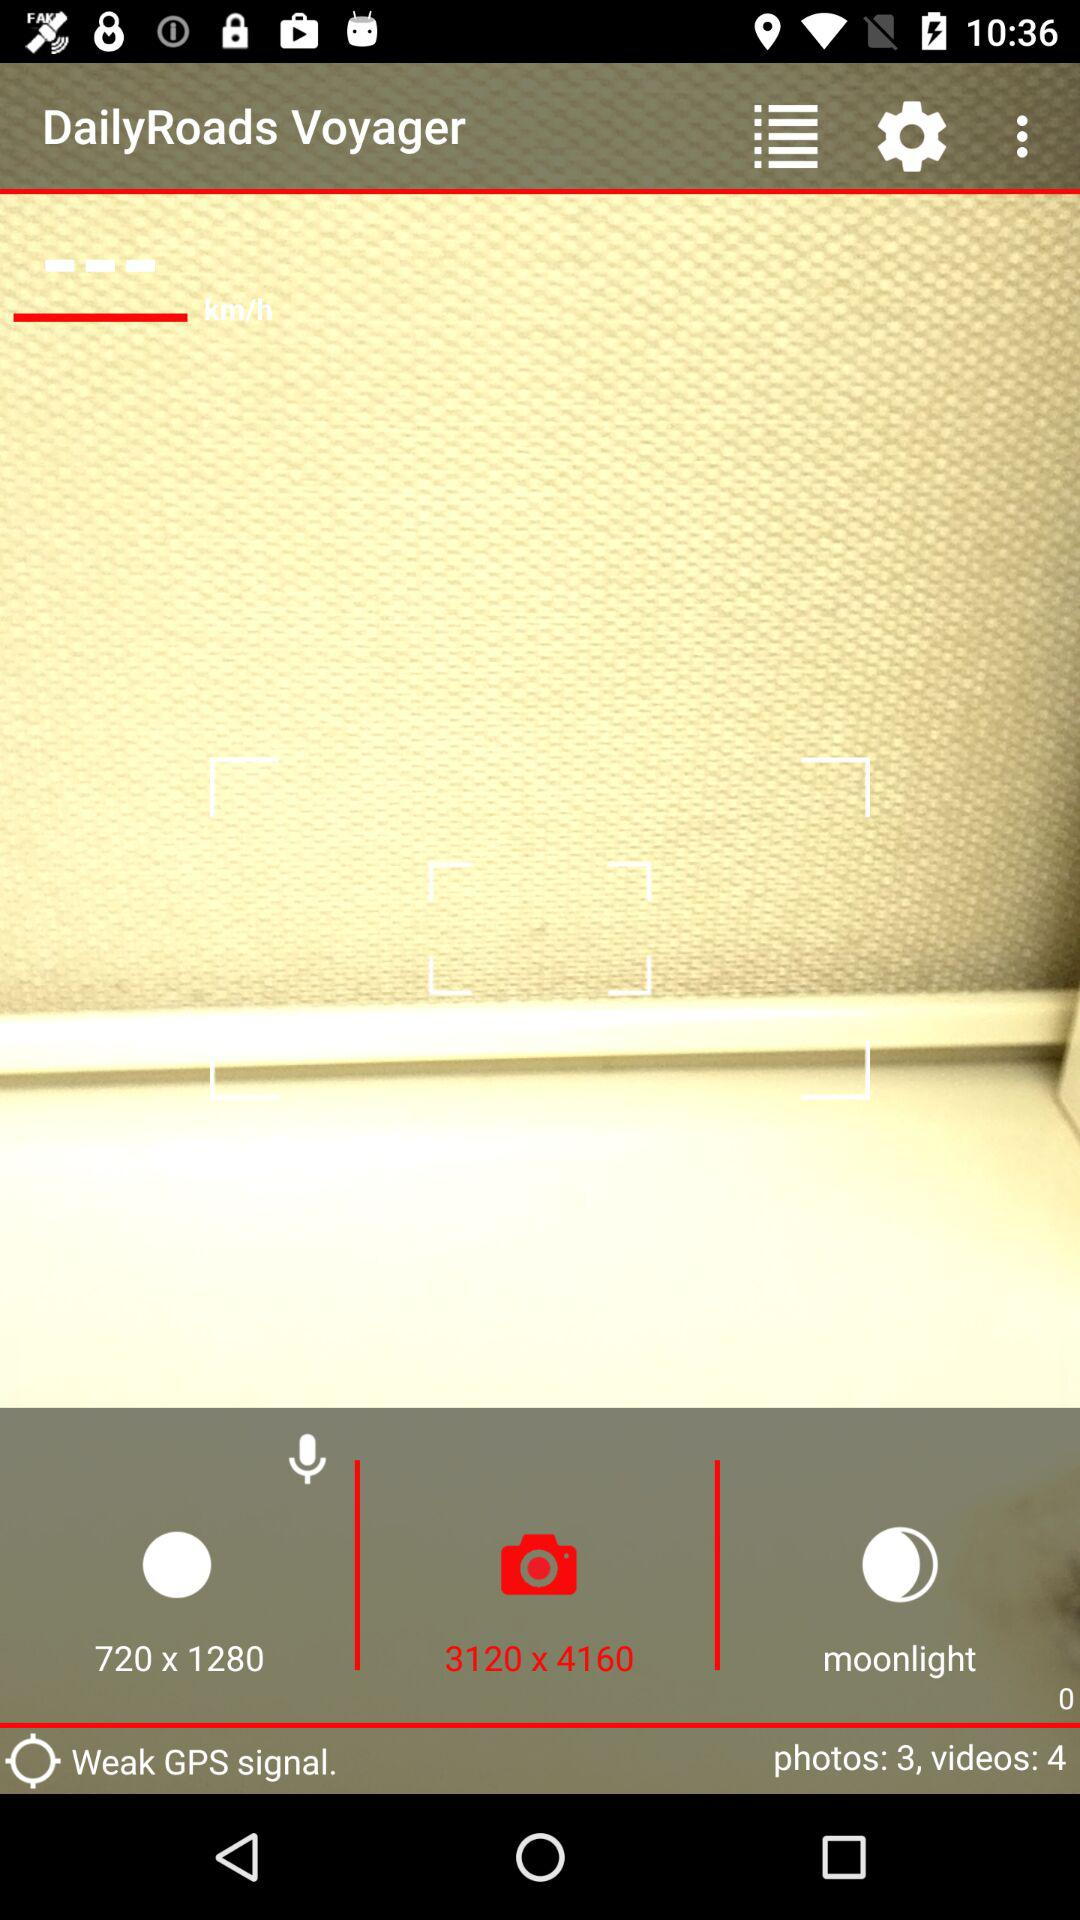How many photos are there? There are 3 photos. 